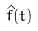<formula> <loc_0><loc_0><loc_500><loc_500>\hat { f } ( t )</formula> 